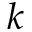Convert formula to latex. <formula><loc_0><loc_0><loc_500><loc_500>k</formula> 